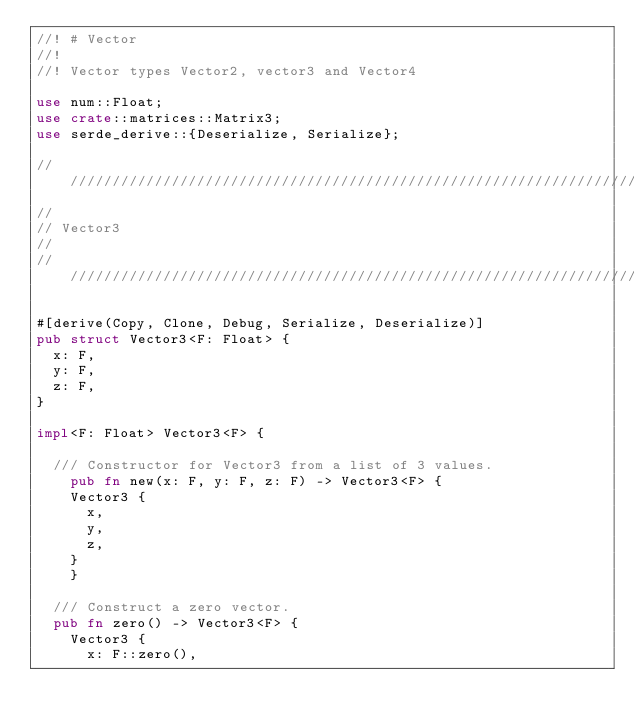Convert code to text. <code><loc_0><loc_0><loc_500><loc_500><_Rust_>//! # Vector
//!
//! Vector types Vector2, vector3 and Vector4

use num::Float;
use crate::matrices::Matrix3;
use serde_derive::{Deserialize, Serialize};

// //////////////////////////////////////////////////////////////////////////////////////
//
// Vector3
//
// //////////////////////////////////////////////////////////////////////////////////////

#[derive(Copy, Clone, Debug, Serialize, Deserialize)]
pub struct Vector3<F: Float> {
	x: F,
	y: F,
	z: F,
}

impl<F: Float> Vector3<F> {

	/// Constructor for Vector3 from a list of 3 values.
    pub fn new(x: F, y: F, z: F) -> Vector3<F> {
		Vector3 {
			x,
			y,
			z,
		}
    }

	/// Construct a zero vector.
	pub fn zero() -> Vector3<F> {
		Vector3 {
			x: F::zero(),</code> 